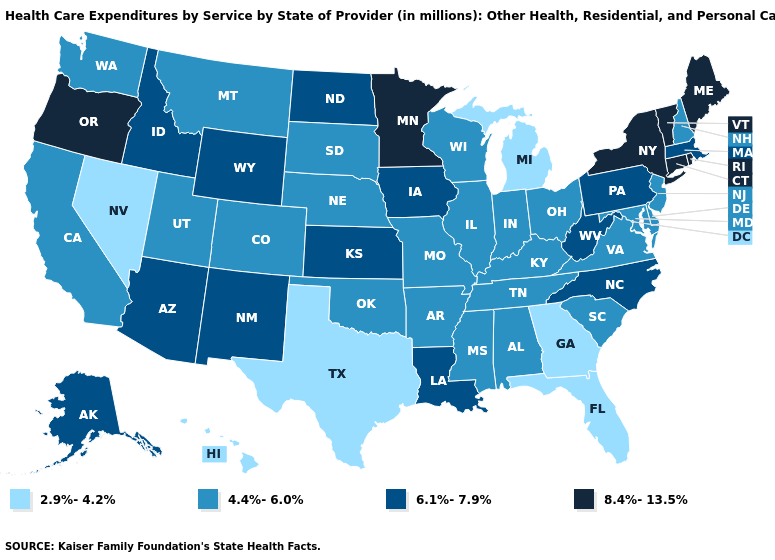Which states hav the highest value in the South?
Answer briefly. Louisiana, North Carolina, West Virginia. Name the states that have a value in the range 6.1%-7.9%?
Answer briefly. Alaska, Arizona, Idaho, Iowa, Kansas, Louisiana, Massachusetts, New Mexico, North Carolina, North Dakota, Pennsylvania, West Virginia, Wyoming. Name the states that have a value in the range 6.1%-7.9%?
Give a very brief answer. Alaska, Arizona, Idaho, Iowa, Kansas, Louisiana, Massachusetts, New Mexico, North Carolina, North Dakota, Pennsylvania, West Virginia, Wyoming. Is the legend a continuous bar?
Write a very short answer. No. What is the value of Alabama?
Be succinct. 4.4%-6.0%. What is the value of Arizona?
Be succinct. 6.1%-7.9%. Does California have the highest value in the USA?
Write a very short answer. No. Does the map have missing data?
Be succinct. No. What is the highest value in the USA?
Quick response, please. 8.4%-13.5%. Does Louisiana have a lower value than Maryland?
Give a very brief answer. No. Which states have the lowest value in the MidWest?
Give a very brief answer. Michigan. Does Utah have a lower value than Kentucky?
Quick response, please. No. Does Idaho have the same value as South Carolina?
Keep it brief. No. Is the legend a continuous bar?
Quick response, please. No. What is the value of Mississippi?
Short answer required. 4.4%-6.0%. 